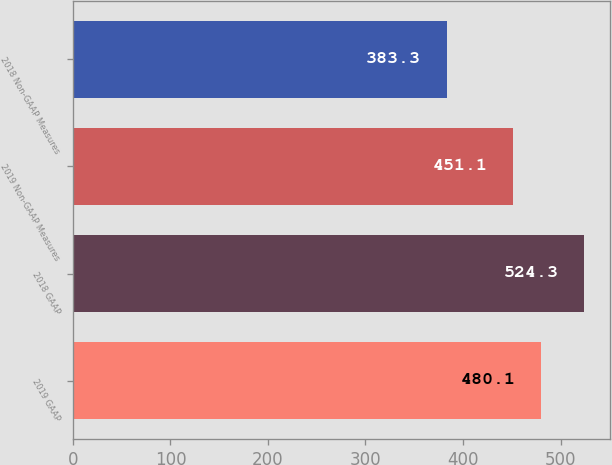Convert chart to OTSL. <chart><loc_0><loc_0><loc_500><loc_500><bar_chart><fcel>2019 GAAP<fcel>2018 GAAP<fcel>2019 Non-GAAP Measures<fcel>2018 Non-GAAP Measures<nl><fcel>480.1<fcel>524.3<fcel>451.1<fcel>383.3<nl></chart> 